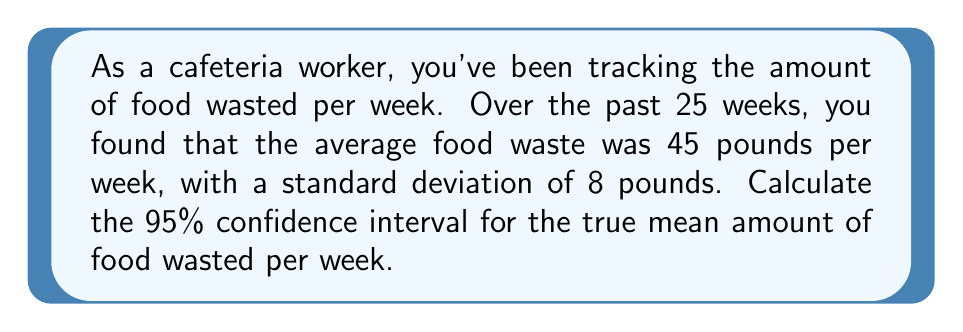What is the answer to this math problem? To calculate the confidence interval, we'll follow these steps:

1. Identify the given information:
   - Sample size (n) = 25 weeks
   - Sample mean (x̄) = 45 pounds
   - Sample standard deviation (s) = 8 pounds
   - Confidence level = 95%

2. Determine the critical value (t-score) for a 95% confidence level with 24 degrees of freedom (n-1):
   t₀.₀₂₅,₂₄ = 2.064 (from t-distribution table)

3. Calculate the standard error (SE) of the mean:
   $$ SE = \frac{s}{\sqrt{n}} = \frac{8}{\sqrt{25}} = 1.6 $$

4. Calculate the margin of error (ME):
   $$ ME = t_{0.025,24} \times SE = 2.064 \times 1.6 = 3.3024 $$

5. Compute the confidence interval:
   Lower bound: $$ 45 - 3.3024 = 41.6976 $$
   Upper bound: $$ 45 + 3.3024 = 48.3024 $$

Therefore, the 95% confidence interval for the true mean amount of food wasted per week is (41.6976, 48.3024) pounds.
Answer: (41.6976, 48.3024) pounds 